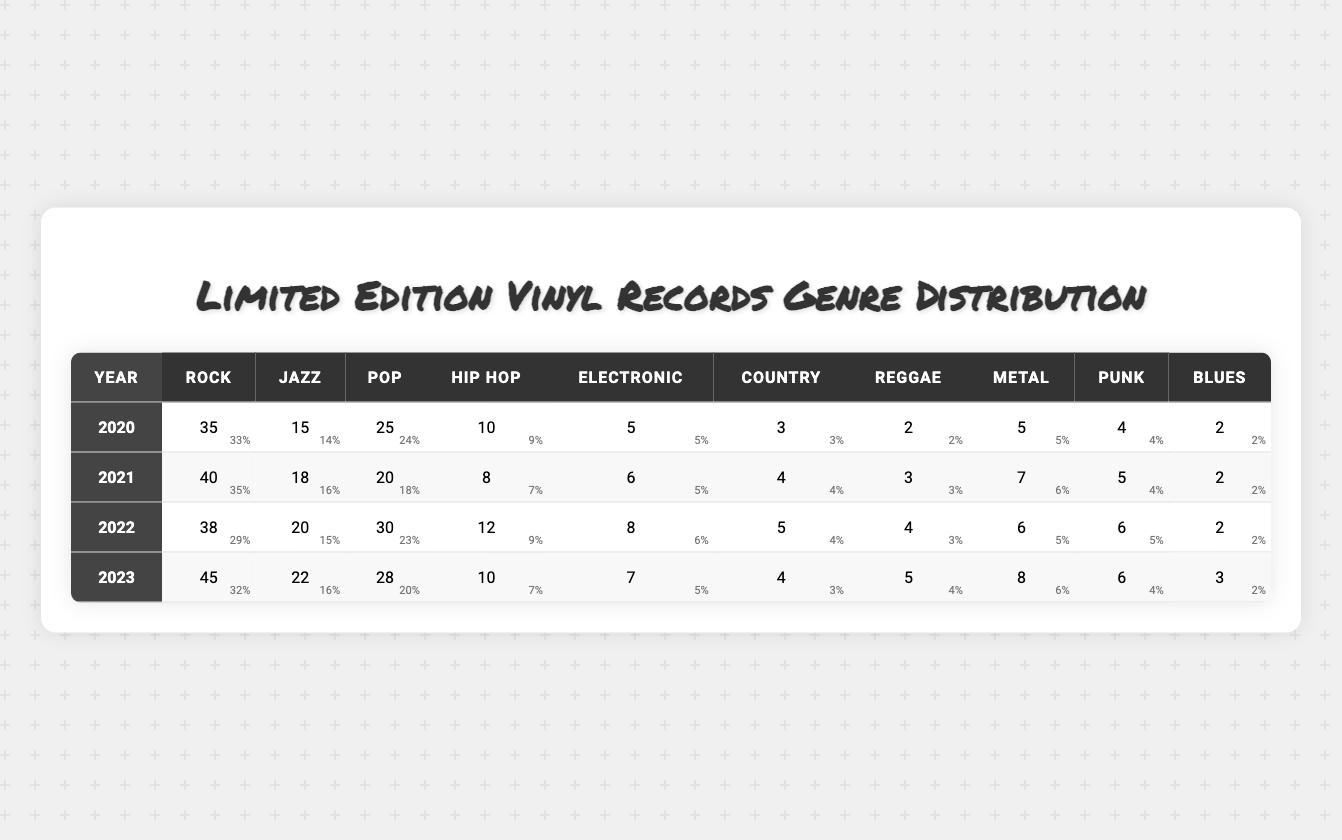What genre had the highest number of limited edition releases in 2020? Looking at the data for 2020, the highest number of releases is in the Rock genre with 35 records.
Answer: Rock How many Blues records were released in 2021? In 2021, the table shows that 2 Blues records were released.
Answer: 2 What was the total number of limited edition vinyl records released in 2022? To find the total for 2022, add all the genres: 38 (Rock) + 20 (Jazz) + 30 (Pop) + 12 (Hip Hop) + 8 (Electronic) + 5 (Country) + 4 (Reggae) + 6 (Metal) + 6 (Punk) + 2 (Blues) = 131.
Answer: 131 In which year were there more Hip Hop releases, 2020 or 2021? In 2020, there were 10 Hip Hop records, while in 2021, there were 8. Since 10 is greater than 8, 2020 had more releases.
Answer: 2020 What was the percentage growth in Rock vinyl releases from 2020 to 2023? Rock releases grew from 35 in 2020 to 45 in 2023. The growth is calculated as ((45 - 35) / 35) * 100 = (10 / 35) * 100 ≈ 28.57%.
Answer: 28.57% Which year saw the lowest number of Country genre releases, and how many were there? The year 2020 had the lowest Country releases with only 3 records.
Answer: 2020, 3 What is the average number of Pop records released over the years 2020 to 2023? For Pop records: (25 + 20 + 30 + 28) / 4 = 103 / 4 = 25.75.
Answer: 25.75 Did the number of Reggae records increase from 2020 to 2023? In 2020, 2 Reggae records were released, and in 2023, there were 5. Since 5 is greater than 2, the number increased.
Answer: Yes What was the total number of Metal and Punk records released in 2021? In 2021, 7 Metal and 5 Punk records were released. The total is 7 + 5 = 12.
Answer: 12 Which genre had a consistent number of releases across all years? By examining the values, Blues consistently had 2 releases in 2020, 2021, and 2022, and 3 in 2023, which shows less variation compared to others.
Answer: Blues 